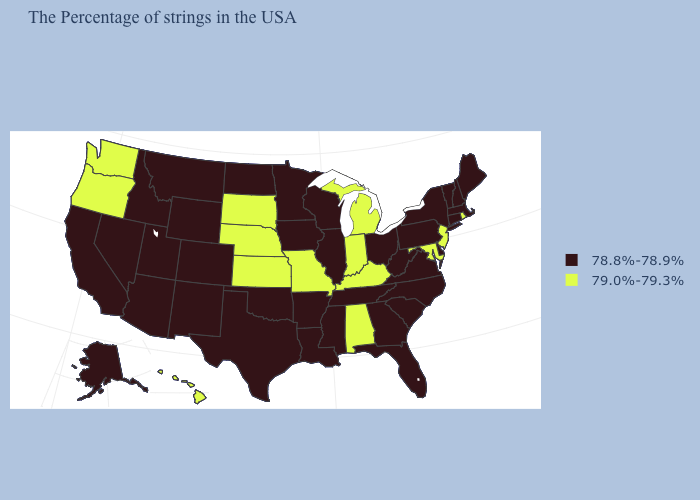Among the states that border Utah , which have the highest value?
Quick response, please. Wyoming, Colorado, New Mexico, Arizona, Idaho, Nevada. What is the value of Nebraska?
Concise answer only. 79.0%-79.3%. Which states have the highest value in the USA?
Concise answer only. Rhode Island, New Jersey, Maryland, Michigan, Kentucky, Indiana, Alabama, Missouri, Kansas, Nebraska, South Dakota, Washington, Oregon, Hawaii. What is the value of Utah?
Give a very brief answer. 78.8%-78.9%. Name the states that have a value in the range 79.0%-79.3%?
Quick response, please. Rhode Island, New Jersey, Maryland, Michigan, Kentucky, Indiana, Alabama, Missouri, Kansas, Nebraska, South Dakota, Washington, Oregon, Hawaii. Is the legend a continuous bar?
Give a very brief answer. No. Is the legend a continuous bar?
Keep it brief. No. Among the states that border South Dakota , which have the highest value?
Answer briefly. Nebraska. Does Michigan have a higher value than New Jersey?
Be succinct. No. What is the highest value in the Northeast ?
Give a very brief answer. 79.0%-79.3%. What is the highest value in the USA?
Answer briefly. 79.0%-79.3%. What is the value of Wisconsin?
Write a very short answer. 78.8%-78.9%. What is the lowest value in states that border California?
Write a very short answer. 78.8%-78.9%. Does North Dakota have the highest value in the MidWest?
Give a very brief answer. No. Name the states that have a value in the range 78.8%-78.9%?
Short answer required. Maine, Massachusetts, New Hampshire, Vermont, Connecticut, New York, Delaware, Pennsylvania, Virginia, North Carolina, South Carolina, West Virginia, Ohio, Florida, Georgia, Tennessee, Wisconsin, Illinois, Mississippi, Louisiana, Arkansas, Minnesota, Iowa, Oklahoma, Texas, North Dakota, Wyoming, Colorado, New Mexico, Utah, Montana, Arizona, Idaho, Nevada, California, Alaska. 